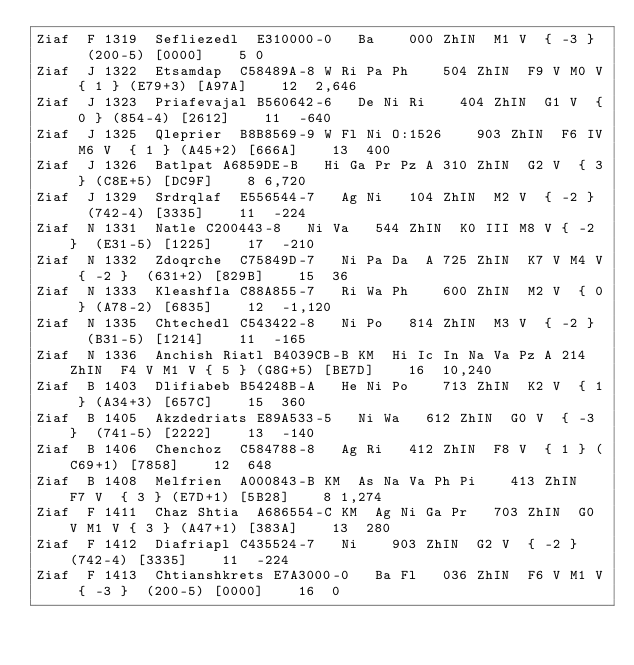Convert code to text. <code><loc_0><loc_0><loc_500><loc_500><_SQL_>Ziaf	F	1319	Sefliezedl	E310000-0		Ba		000	ZhIN	M1 V	{ -3 }	(200-5)	[0000]		5	0
Ziaf	J	1322	Etsamdap	C58489A-8	W	Ri Pa Ph		504	ZhIN	F9 V M0 V	{ 1 }	(E79+3)	[A97A]		12	2,646
Ziaf	J	1323	Priafevajal	B560642-6		De Ni Ri		404	ZhIN	G1 V	{ 0 }	(854-4)	[2612]		11	-640
Ziaf	J	1325	Qleprier	B8B8569-9	W	Fl Ni O:1526		903	ZhIN	F6 IV M6 V	{ 1 }	(A45+2)	[666A]		13	400
Ziaf	J	1326	Batlpat	A6859DE-B		Hi Ga Pr Pz	A	310	ZhIN	G2 V	{ 3 }	(C8E+5)	[DC9F]		8	6,720
Ziaf	J	1329	Srdrqlaf	E556544-7		Ag Ni		104	ZhIN	M2 V	{ -2 }	(742-4)	[3335]		11	-224
Ziaf	N	1331	Natle	C200443-8		Ni Va		544	ZhIN	K0 III M8 V	{ -2 }	(E31-5)	[1225]		17	-210
Ziaf	N	1332	Zdoqrche	C75849D-7		Ni Pa Da	A	725	ZhIN	K7 V M4 V	{ -2 }	(631+2)	[829B]		15	36
Ziaf	N	1333	Kleashfla	C88A855-7		Ri Wa Ph		600	ZhIN	M2 V	{ 0 }	(A78-2)	[6835]		12	-1,120
Ziaf	N	1335	Chtechedl	C543422-8		Ni Po		814	ZhIN	M3 V	{ -2 }	(B31-5)	[1214]		11	-165
Ziaf	N	1336	Anchish Riatl	B4039CB-B	KM	Hi Ic In Na Va Pz	A	214	ZhIN	F4 V M1 V	{ 5 }	(G8G+5)	[BE7D]		16	10,240
Ziaf	B	1403	Dlifiabeb	B54248B-A		He Ni Po		713	ZhIN	K2 V	{ 1 }	(A34+3)	[657C]		15	360
Ziaf	B	1405	Akzdedriats	E89A533-5		Ni Wa		612	ZhIN	G0 V	{ -3 }	(741-5)	[2222]		13	-140
Ziaf	B	1406	Chenchoz	C584788-8		Ag Ri		412	ZhIN	F8 V	{ 1 }	(C69+1)	[7858]		12	648
Ziaf	B	1408	Melfrien	A000843-B	KM	As Na Va Ph Pi		413	ZhIN	F7 V	{ 3 }	(E7D+1)	[5B28]		8	1,274
Ziaf	F	1411	Chaz Shtia	A686554-C	KM	Ag Ni Ga Pr		703	ZhIN	G0 V M1 V	{ 3 }	(A47+1)	[383A]		13	280
Ziaf	F	1412	Diafriapl	C435524-7		Ni		903	ZhIN	G2 V	{ -2 }	(742-4)	[3335]		11	-224
Ziaf	F	1413	Chtianshkrets	E7A3000-0		Ba Fl		036	ZhIN	F6 V M1 V	{ -3 }	(200-5)	[0000]		16	0</code> 